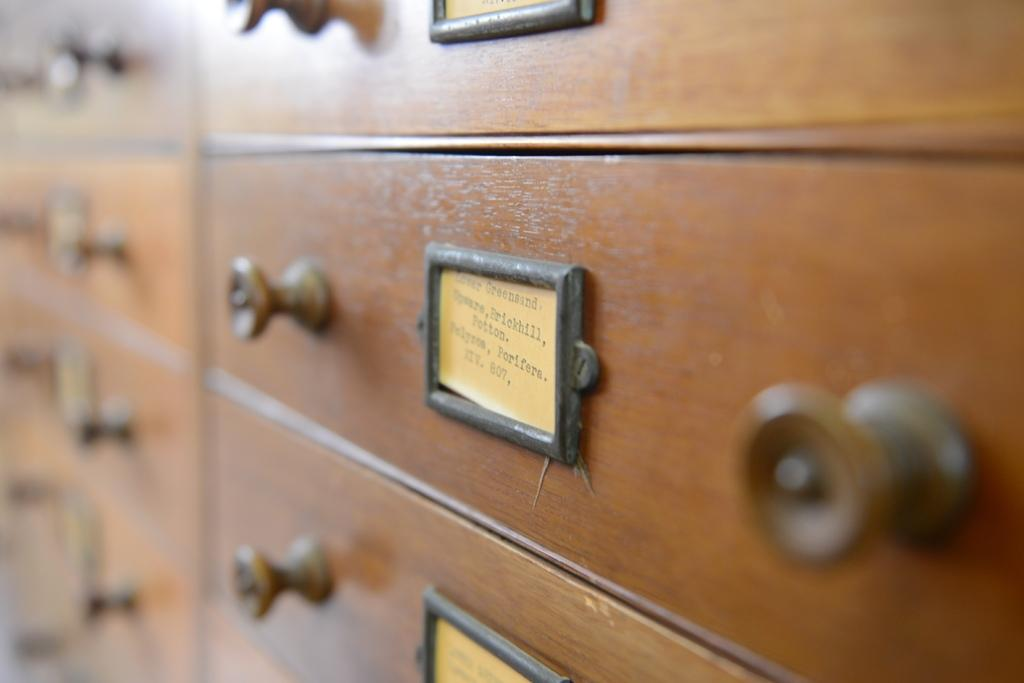What type of objects are made of wood in the image? There are wooden boxes in the image. What is the other object made of in the image? The paper is made of paper. Where is the paper located in the image? The paper is kept inside a black object. What type of letters can be seen engraved on the wooden boxes in the image? There are no letters engraved on the wooden boxes in the image. 